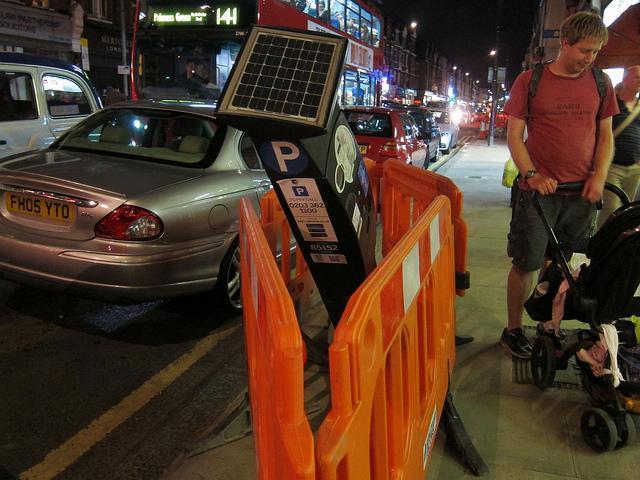Which make of vehicle is parked nearest to the meter?
Choose the correct response and explain in the format: 'Answer: answer
Rationale: rationale.'
Options: Honda, jaguar, bmw, toyota. Answer: jaguar.
Rationale: The car is made by jaguar. 